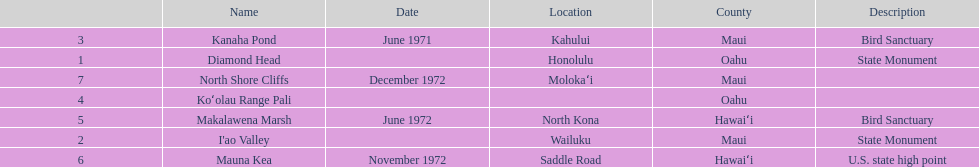What are the total number of landmarks located in maui? 3. 